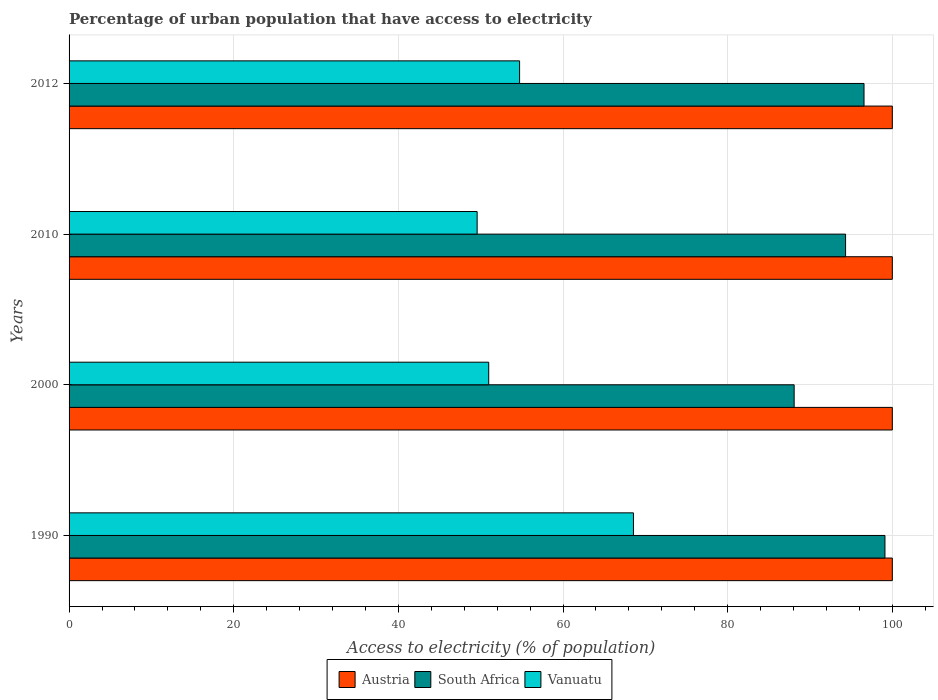How many different coloured bars are there?
Give a very brief answer. 3. How many groups of bars are there?
Your response must be concise. 4. How many bars are there on the 3rd tick from the bottom?
Keep it short and to the point. 3. What is the percentage of urban population that have access to electricity in Vanuatu in 1990?
Offer a very short reply. 68.56. Across all years, what is the maximum percentage of urban population that have access to electricity in Vanuatu?
Give a very brief answer. 68.56. Across all years, what is the minimum percentage of urban population that have access to electricity in Vanuatu?
Ensure brevity in your answer.  49.57. In which year was the percentage of urban population that have access to electricity in Vanuatu maximum?
Provide a short and direct response. 1990. In which year was the percentage of urban population that have access to electricity in South Africa minimum?
Make the answer very short. 2000. What is the total percentage of urban population that have access to electricity in Vanuatu in the graph?
Keep it short and to the point. 223.82. What is the difference between the percentage of urban population that have access to electricity in Vanuatu in 1990 and that in 2000?
Your answer should be compact. 17.58. What is the difference between the percentage of urban population that have access to electricity in Vanuatu in 2000 and the percentage of urban population that have access to electricity in South Africa in 2012?
Keep it short and to the point. -45.59. What is the average percentage of urban population that have access to electricity in Austria per year?
Give a very brief answer. 100. In the year 2000, what is the difference between the percentage of urban population that have access to electricity in Austria and percentage of urban population that have access to electricity in Vanuatu?
Ensure brevity in your answer.  49.03. In how many years, is the percentage of urban population that have access to electricity in Vanuatu greater than 52 %?
Your answer should be very brief. 2. Is the percentage of urban population that have access to electricity in Vanuatu in 2000 less than that in 2012?
Ensure brevity in your answer.  Yes. What is the difference between the highest and the second highest percentage of urban population that have access to electricity in Vanuatu?
Ensure brevity in your answer.  13.83. What is the difference between the highest and the lowest percentage of urban population that have access to electricity in Vanuatu?
Ensure brevity in your answer.  18.99. In how many years, is the percentage of urban population that have access to electricity in Vanuatu greater than the average percentage of urban population that have access to electricity in Vanuatu taken over all years?
Provide a short and direct response. 1. Is the sum of the percentage of urban population that have access to electricity in South Africa in 1990 and 2000 greater than the maximum percentage of urban population that have access to electricity in Vanuatu across all years?
Keep it short and to the point. Yes. What does the 2nd bar from the top in 2012 represents?
Keep it short and to the point. South Africa. How many bars are there?
Provide a short and direct response. 12. How many years are there in the graph?
Offer a very short reply. 4. What is the difference between two consecutive major ticks on the X-axis?
Make the answer very short. 20. Are the values on the major ticks of X-axis written in scientific E-notation?
Your response must be concise. No. Does the graph contain any zero values?
Your answer should be very brief. No. Does the graph contain grids?
Give a very brief answer. Yes. How are the legend labels stacked?
Your answer should be very brief. Horizontal. What is the title of the graph?
Keep it short and to the point. Percentage of urban population that have access to electricity. What is the label or title of the X-axis?
Make the answer very short. Access to electricity (% of population). What is the Access to electricity (% of population) in Austria in 1990?
Give a very brief answer. 100. What is the Access to electricity (% of population) of South Africa in 1990?
Your answer should be compact. 99.1. What is the Access to electricity (% of population) in Vanuatu in 1990?
Make the answer very short. 68.56. What is the Access to electricity (% of population) in South Africa in 2000?
Offer a terse response. 88.07. What is the Access to electricity (% of population) of Vanuatu in 2000?
Your answer should be compact. 50.97. What is the Access to electricity (% of population) in South Africa in 2010?
Provide a short and direct response. 94.32. What is the Access to electricity (% of population) in Vanuatu in 2010?
Provide a short and direct response. 49.57. What is the Access to electricity (% of population) in South Africa in 2012?
Provide a succinct answer. 96.56. What is the Access to electricity (% of population) of Vanuatu in 2012?
Provide a succinct answer. 54.72. Across all years, what is the maximum Access to electricity (% of population) of South Africa?
Give a very brief answer. 99.1. Across all years, what is the maximum Access to electricity (% of population) of Vanuatu?
Make the answer very short. 68.56. Across all years, what is the minimum Access to electricity (% of population) in South Africa?
Give a very brief answer. 88.07. Across all years, what is the minimum Access to electricity (% of population) of Vanuatu?
Provide a succinct answer. 49.57. What is the total Access to electricity (% of population) of South Africa in the graph?
Your response must be concise. 378.06. What is the total Access to electricity (% of population) in Vanuatu in the graph?
Your answer should be very brief. 223.82. What is the difference between the Access to electricity (% of population) of South Africa in 1990 and that in 2000?
Offer a very short reply. 11.03. What is the difference between the Access to electricity (% of population) of Vanuatu in 1990 and that in 2000?
Keep it short and to the point. 17.58. What is the difference between the Access to electricity (% of population) in Austria in 1990 and that in 2010?
Offer a terse response. 0. What is the difference between the Access to electricity (% of population) of South Africa in 1990 and that in 2010?
Keep it short and to the point. 4.78. What is the difference between the Access to electricity (% of population) of Vanuatu in 1990 and that in 2010?
Give a very brief answer. 18.99. What is the difference between the Access to electricity (% of population) of South Africa in 1990 and that in 2012?
Your answer should be compact. 2.54. What is the difference between the Access to electricity (% of population) in Vanuatu in 1990 and that in 2012?
Offer a terse response. 13.83. What is the difference between the Access to electricity (% of population) of South Africa in 2000 and that in 2010?
Your response must be concise. -6.25. What is the difference between the Access to electricity (% of population) of Vanuatu in 2000 and that in 2010?
Give a very brief answer. 1.41. What is the difference between the Access to electricity (% of population) in Austria in 2000 and that in 2012?
Your response must be concise. 0. What is the difference between the Access to electricity (% of population) of South Africa in 2000 and that in 2012?
Offer a terse response. -8.49. What is the difference between the Access to electricity (% of population) in Vanuatu in 2000 and that in 2012?
Offer a very short reply. -3.75. What is the difference between the Access to electricity (% of population) of South Africa in 2010 and that in 2012?
Provide a succinct answer. -2.24. What is the difference between the Access to electricity (% of population) of Vanuatu in 2010 and that in 2012?
Give a very brief answer. -5.16. What is the difference between the Access to electricity (% of population) in Austria in 1990 and the Access to electricity (% of population) in South Africa in 2000?
Your response must be concise. 11.93. What is the difference between the Access to electricity (% of population) in Austria in 1990 and the Access to electricity (% of population) in Vanuatu in 2000?
Your answer should be compact. 49.03. What is the difference between the Access to electricity (% of population) in South Africa in 1990 and the Access to electricity (% of population) in Vanuatu in 2000?
Provide a short and direct response. 48.13. What is the difference between the Access to electricity (% of population) of Austria in 1990 and the Access to electricity (% of population) of South Africa in 2010?
Provide a short and direct response. 5.68. What is the difference between the Access to electricity (% of population) in Austria in 1990 and the Access to electricity (% of population) in Vanuatu in 2010?
Your answer should be very brief. 50.43. What is the difference between the Access to electricity (% of population) in South Africa in 1990 and the Access to electricity (% of population) in Vanuatu in 2010?
Ensure brevity in your answer.  49.53. What is the difference between the Access to electricity (% of population) of Austria in 1990 and the Access to electricity (% of population) of South Africa in 2012?
Offer a very short reply. 3.44. What is the difference between the Access to electricity (% of population) of Austria in 1990 and the Access to electricity (% of population) of Vanuatu in 2012?
Give a very brief answer. 45.27. What is the difference between the Access to electricity (% of population) in South Africa in 1990 and the Access to electricity (% of population) in Vanuatu in 2012?
Make the answer very short. 44.38. What is the difference between the Access to electricity (% of population) of Austria in 2000 and the Access to electricity (% of population) of South Africa in 2010?
Keep it short and to the point. 5.68. What is the difference between the Access to electricity (% of population) in Austria in 2000 and the Access to electricity (% of population) in Vanuatu in 2010?
Make the answer very short. 50.43. What is the difference between the Access to electricity (% of population) in South Africa in 2000 and the Access to electricity (% of population) in Vanuatu in 2010?
Give a very brief answer. 38.51. What is the difference between the Access to electricity (% of population) in Austria in 2000 and the Access to electricity (% of population) in South Africa in 2012?
Ensure brevity in your answer.  3.44. What is the difference between the Access to electricity (% of population) of Austria in 2000 and the Access to electricity (% of population) of Vanuatu in 2012?
Your response must be concise. 45.27. What is the difference between the Access to electricity (% of population) in South Africa in 2000 and the Access to electricity (% of population) in Vanuatu in 2012?
Make the answer very short. 33.35. What is the difference between the Access to electricity (% of population) of Austria in 2010 and the Access to electricity (% of population) of South Africa in 2012?
Provide a succinct answer. 3.44. What is the difference between the Access to electricity (% of population) of Austria in 2010 and the Access to electricity (% of population) of Vanuatu in 2012?
Offer a very short reply. 45.27. What is the difference between the Access to electricity (% of population) in South Africa in 2010 and the Access to electricity (% of population) in Vanuatu in 2012?
Provide a succinct answer. 39.6. What is the average Access to electricity (% of population) of South Africa per year?
Make the answer very short. 94.52. What is the average Access to electricity (% of population) in Vanuatu per year?
Offer a very short reply. 55.96. In the year 1990, what is the difference between the Access to electricity (% of population) of Austria and Access to electricity (% of population) of South Africa?
Offer a terse response. 0.9. In the year 1990, what is the difference between the Access to electricity (% of population) in Austria and Access to electricity (% of population) in Vanuatu?
Your answer should be compact. 31.44. In the year 1990, what is the difference between the Access to electricity (% of population) in South Africa and Access to electricity (% of population) in Vanuatu?
Your answer should be compact. 30.55. In the year 2000, what is the difference between the Access to electricity (% of population) in Austria and Access to electricity (% of population) in South Africa?
Your answer should be very brief. 11.93. In the year 2000, what is the difference between the Access to electricity (% of population) in Austria and Access to electricity (% of population) in Vanuatu?
Give a very brief answer. 49.03. In the year 2000, what is the difference between the Access to electricity (% of population) in South Africa and Access to electricity (% of population) in Vanuatu?
Keep it short and to the point. 37.1. In the year 2010, what is the difference between the Access to electricity (% of population) in Austria and Access to electricity (% of population) in South Africa?
Ensure brevity in your answer.  5.68. In the year 2010, what is the difference between the Access to electricity (% of population) in Austria and Access to electricity (% of population) in Vanuatu?
Provide a succinct answer. 50.43. In the year 2010, what is the difference between the Access to electricity (% of population) of South Africa and Access to electricity (% of population) of Vanuatu?
Make the answer very short. 44.75. In the year 2012, what is the difference between the Access to electricity (% of population) of Austria and Access to electricity (% of population) of South Africa?
Keep it short and to the point. 3.44. In the year 2012, what is the difference between the Access to electricity (% of population) in Austria and Access to electricity (% of population) in Vanuatu?
Provide a succinct answer. 45.27. In the year 2012, what is the difference between the Access to electricity (% of population) of South Africa and Access to electricity (% of population) of Vanuatu?
Keep it short and to the point. 41.84. What is the ratio of the Access to electricity (% of population) of Austria in 1990 to that in 2000?
Your answer should be very brief. 1. What is the ratio of the Access to electricity (% of population) in South Africa in 1990 to that in 2000?
Give a very brief answer. 1.13. What is the ratio of the Access to electricity (% of population) in Vanuatu in 1990 to that in 2000?
Your answer should be very brief. 1.34. What is the ratio of the Access to electricity (% of population) in Austria in 1990 to that in 2010?
Offer a terse response. 1. What is the ratio of the Access to electricity (% of population) in South Africa in 1990 to that in 2010?
Make the answer very short. 1.05. What is the ratio of the Access to electricity (% of population) in Vanuatu in 1990 to that in 2010?
Your response must be concise. 1.38. What is the ratio of the Access to electricity (% of population) in South Africa in 1990 to that in 2012?
Offer a terse response. 1.03. What is the ratio of the Access to electricity (% of population) of Vanuatu in 1990 to that in 2012?
Offer a very short reply. 1.25. What is the ratio of the Access to electricity (% of population) of South Africa in 2000 to that in 2010?
Give a very brief answer. 0.93. What is the ratio of the Access to electricity (% of population) of Vanuatu in 2000 to that in 2010?
Your answer should be very brief. 1.03. What is the ratio of the Access to electricity (% of population) of Austria in 2000 to that in 2012?
Provide a short and direct response. 1. What is the ratio of the Access to electricity (% of population) of South Africa in 2000 to that in 2012?
Ensure brevity in your answer.  0.91. What is the ratio of the Access to electricity (% of population) in Vanuatu in 2000 to that in 2012?
Ensure brevity in your answer.  0.93. What is the ratio of the Access to electricity (% of population) in South Africa in 2010 to that in 2012?
Offer a terse response. 0.98. What is the ratio of the Access to electricity (% of population) in Vanuatu in 2010 to that in 2012?
Your response must be concise. 0.91. What is the difference between the highest and the second highest Access to electricity (% of population) of Austria?
Offer a very short reply. 0. What is the difference between the highest and the second highest Access to electricity (% of population) of South Africa?
Offer a very short reply. 2.54. What is the difference between the highest and the second highest Access to electricity (% of population) in Vanuatu?
Make the answer very short. 13.83. What is the difference between the highest and the lowest Access to electricity (% of population) of Austria?
Offer a terse response. 0. What is the difference between the highest and the lowest Access to electricity (% of population) in South Africa?
Provide a succinct answer. 11.03. What is the difference between the highest and the lowest Access to electricity (% of population) of Vanuatu?
Give a very brief answer. 18.99. 